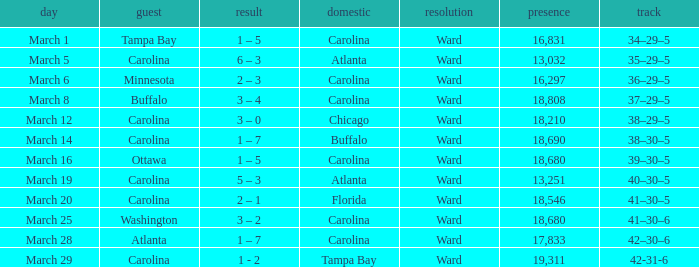What is the Record when Buffalo is at Home? 38–30–5. 